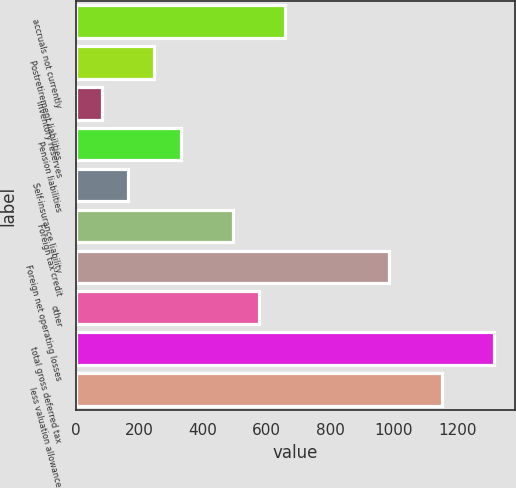Convert chart to OTSL. <chart><loc_0><loc_0><loc_500><loc_500><bar_chart><fcel>accruals not currently<fcel>Postretirement liabilities<fcel>inventory reserves<fcel>Pension liabilities<fcel>Self-insurance liability<fcel>Foreign tax credit<fcel>Foreign net operating losses<fcel>other<fcel>total gross deferred tax<fcel>less valuation allowance<nl><fcel>657.42<fcel>246.72<fcel>82.44<fcel>328.86<fcel>164.58<fcel>493.14<fcel>985.98<fcel>575.28<fcel>1314.54<fcel>1150.26<nl></chart> 